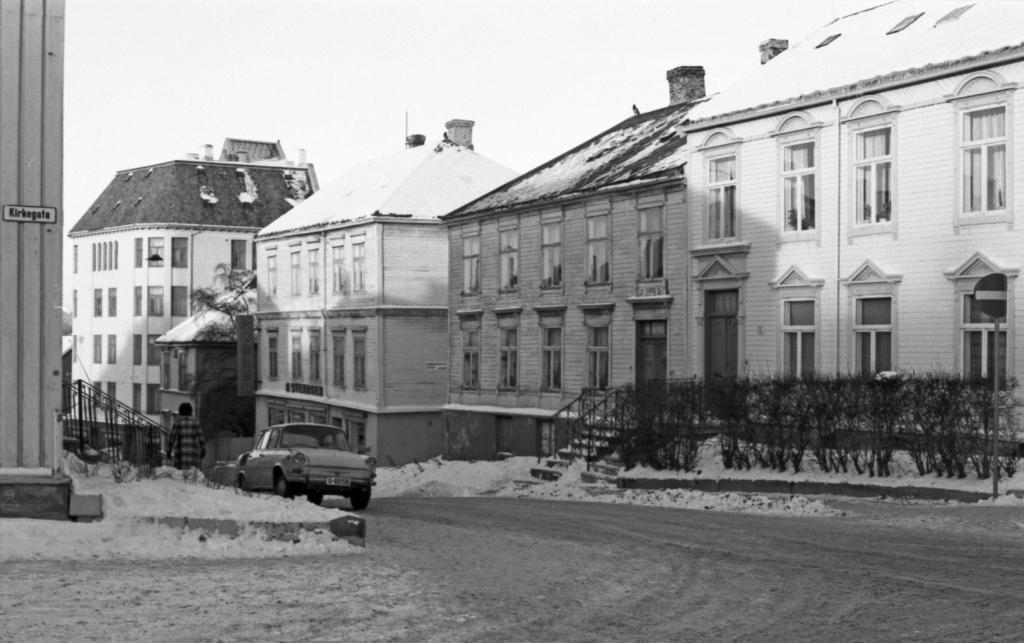In one or two sentences, can you explain what this image depicts? In this picture there are houses in the center of the image and there are plants in the image and there is a man and a car on the left side of the image, there is a pillar on the left side of the image, it seems to be there is snow in the image. 